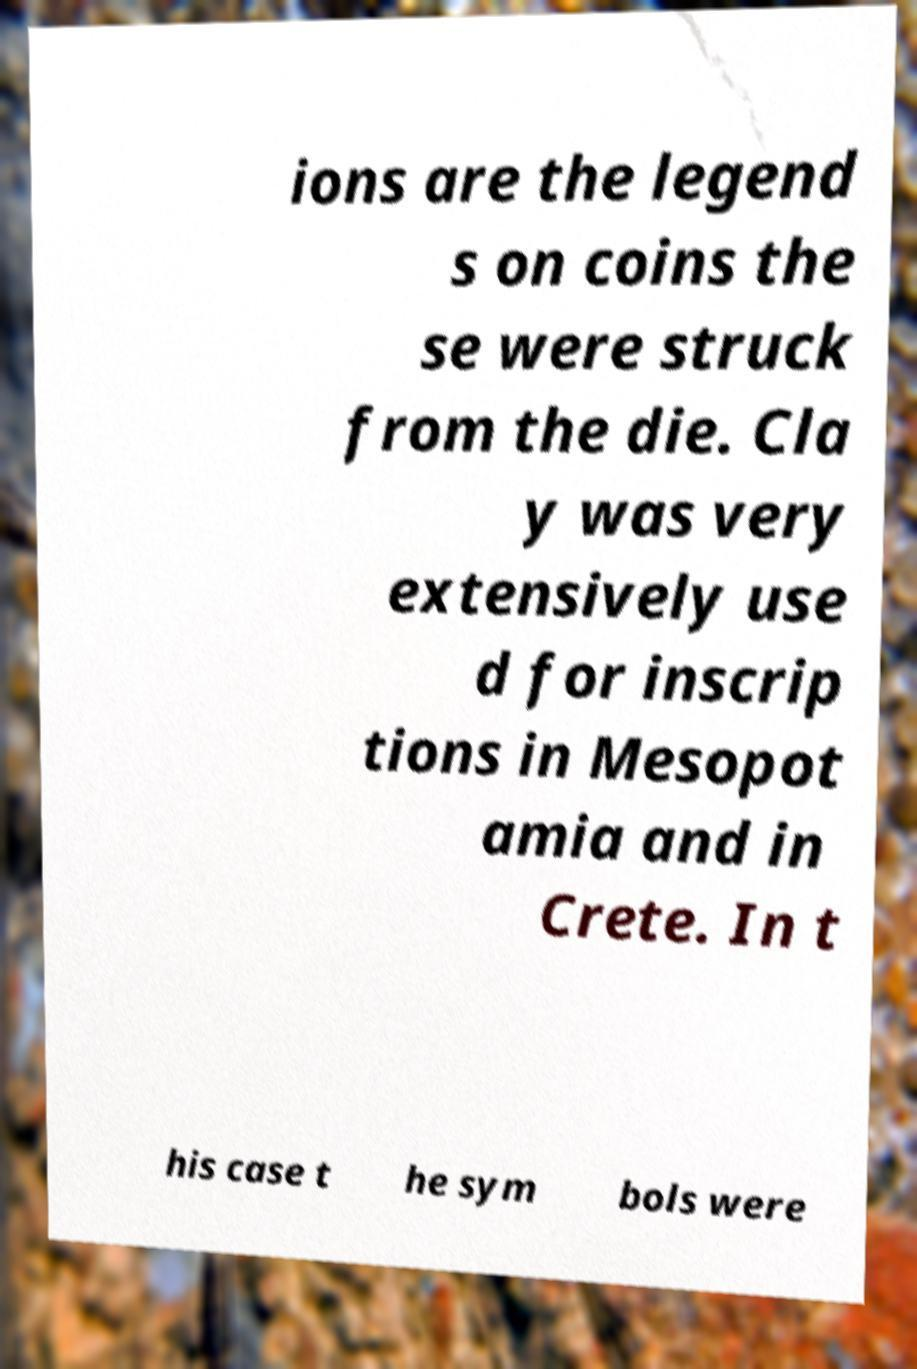What messages or text are displayed in this image? I need them in a readable, typed format. ions are the legend s on coins the se were struck from the die. Cla y was very extensively use d for inscrip tions in Mesopot amia and in Crete. In t his case t he sym bols were 